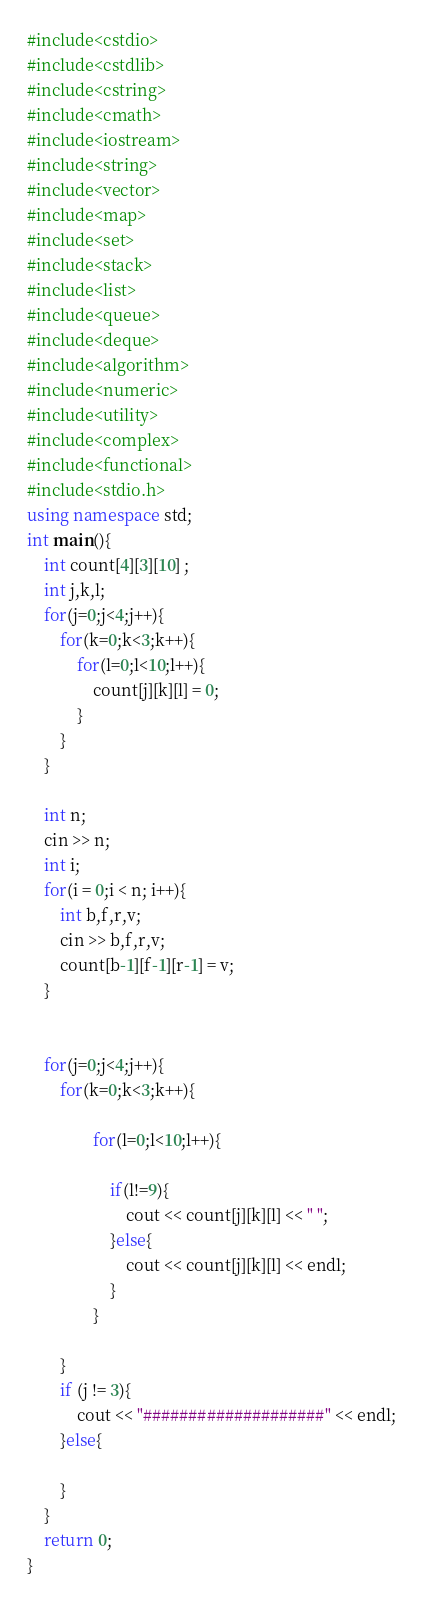<code> <loc_0><loc_0><loc_500><loc_500><_C++_>#include<cstdio>
#include<cstdlib>
#include<cstring>
#include<cmath>
#include<iostream>
#include<string>
#include<vector>
#include<map>
#include<set>
#include<stack>
#include<list>
#include<queue>
#include<deque>
#include<algorithm>
#include<numeric>
#include<utility>
#include<complex>
#include<functional>
#include<stdio.h>
using namespace std;
int main(){
    int count[4][3][10] ;
    int j,k,l;
    for(j=0;j<4;j++){
        for(k=0;k<3;k++){
            for(l=0;l<10;l++){
                count[j][k][l] = 0;
            }
        }
    }

    int n;
    cin >> n;
    int i;
    for(i = 0;i < n; i++){
        int b,f,r,v;
        cin >> b,f,r,v;
        count[b-1][f-1][r-1] = v;
    }


    for(j=0;j<4;j++){
        for(k=0;k<3;k++){

                for(l=0;l<10;l++){

                    if(l!=9){
                        cout << count[j][k][l] << " ";
                    }else{
                        cout << count[j][k][l] << endl;
                    }
                }

        }
        if (j != 3){
            cout << "####################" << endl;
        }else{

        }
    }
    return 0;
}
</code> 